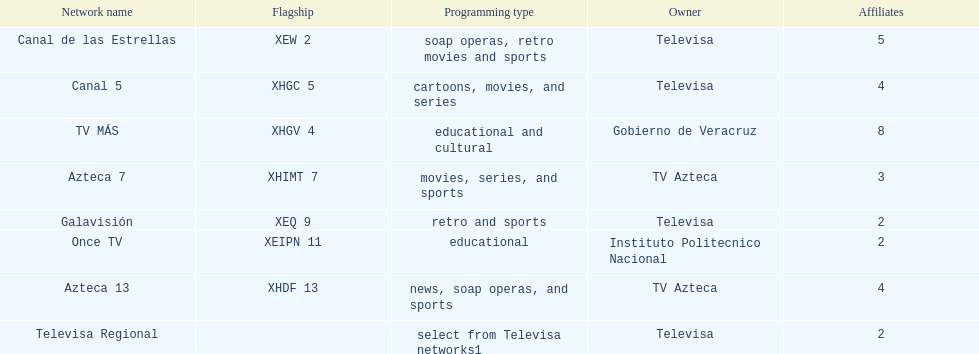Which proprietor possesses the most networks? Televisa. 